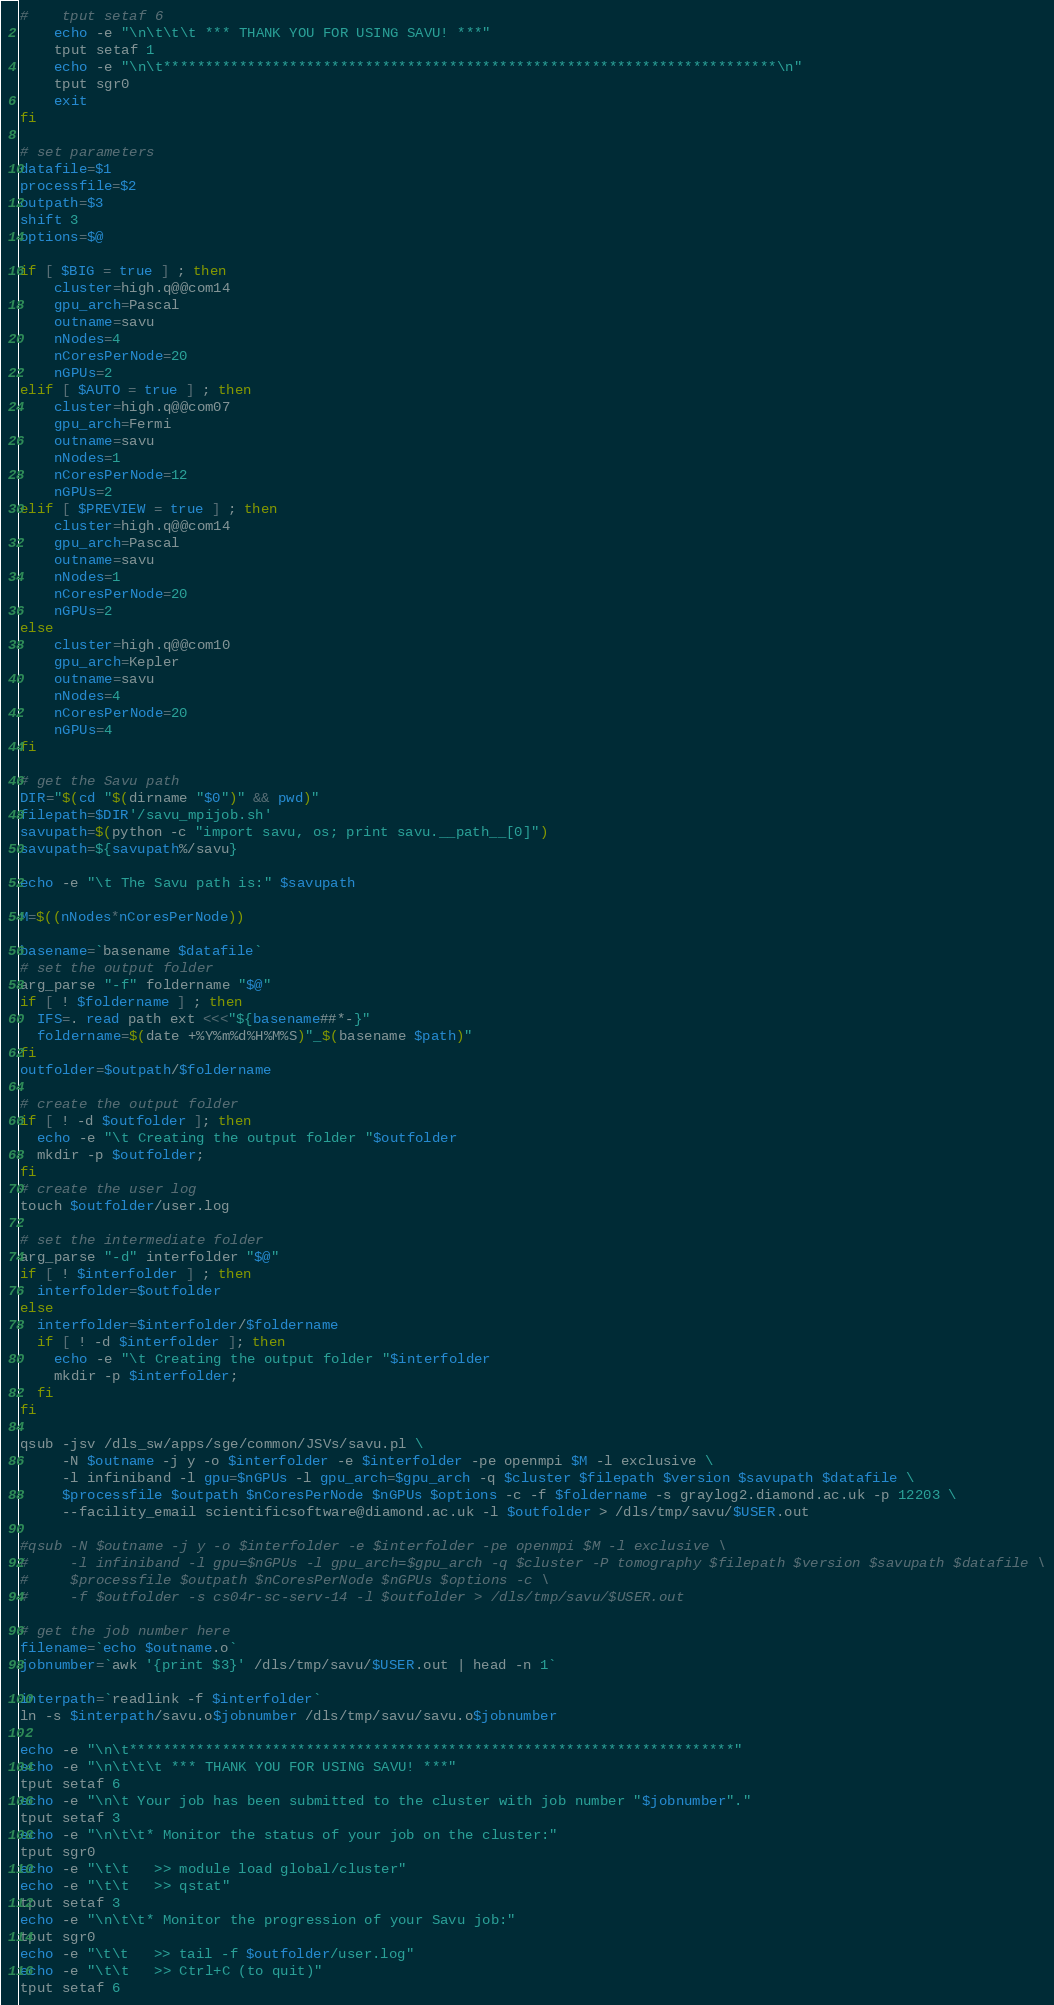<code> <loc_0><loc_0><loc_500><loc_500><_Bash_>#    tput setaf 6
    echo -e "\n\t\t\t *** THANK YOU FOR USING SAVU! ***"
    tput setaf 1
    echo -e "\n\t*************************************************************************\n"
    tput sgr0
    exit
fi

# set parameters
datafile=$1
processfile=$2
outpath=$3
shift 3
options=$@

if [ $BIG = true ] ; then
    cluster=high.q@@com14
    gpu_arch=Pascal
    outname=savu
    nNodes=4
    nCoresPerNode=20
    nGPUs=2
elif [ $AUTO = true ] ; then
    cluster=high.q@@com07
    gpu_arch=Fermi
    outname=savu
    nNodes=1
    nCoresPerNode=12
    nGPUs=2
elif [ $PREVIEW = true ] ; then
    cluster=high.q@@com14
    gpu_arch=Pascal
    outname=savu
    nNodes=1
    nCoresPerNode=20
    nGPUs=2
else
    cluster=high.q@@com10
    gpu_arch=Kepler
    outname=savu
    nNodes=4
    nCoresPerNode=20
    nGPUs=4
fi

# get the Savu path
DIR="$(cd "$(dirname "$0")" && pwd)"
filepath=$DIR'/savu_mpijob.sh'
savupath=$(python -c "import savu, os; print savu.__path__[0]")
savupath=${savupath%/savu}

echo -e "\t The Savu path is:" $savupath

M=$((nNodes*nCoresPerNode))

basename=`basename $datafile`
# set the output folder
arg_parse "-f" foldername "$@"
if [ ! $foldername ] ; then
  IFS=. read path ext <<<"${basename##*-}"
  foldername=$(date +%Y%m%d%H%M%S)"_$(basename $path)"
fi
outfolder=$outpath/$foldername

# create the output folder
if [ ! -d $outfolder ]; then
  echo -e "\t Creating the output folder "$outfolder
  mkdir -p $outfolder;
fi
# create the user log
touch $outfolder/user.log

# set the intermediate folder
arg_parse "-d" interfolder "$@"
if [ ! $interfolder ] ; then
  interfolder=$outfolder
else
  interfolder=$interfolder/$foldername
  if [ ! -d $interfolder ]; then
    echo -e "\t Creating the output folder "$interfolder
    mkdir -p $interfolder;
  fi
fi

qsub -jsv /dls_sw/apps/sge/common/JSVs/savu.pl \
     -N $outname -j y -o $interfolder -e $interfolder -pe openmpi $M -l exclusive \
     -l infiniband -l gpu=$nGPUs -l gpu_arch=$gpu_arch -q $cluster $filepath $version $savupath $datafile \
     $processfile $outpath $nCoresPerNode $nGPUs $options -c -f $foldername -s graylog2.diamond.ac.uk -p 12203 \
     --facility_email scientificsoftware@diamond.ac.uk -l $outfolder > /dls/tmp/savu/$USER.out

#qsub -N $outname -j y -o $interfolder -e $interfolder -pe openmpi $M -l exclusive \
#     -l infiniband -l gpu=$nGPUs -l gpu_arch=$gpu_arch -q $cluster -P tomography $filepath $version $savupath $datafile \
#     $processfile $outpath $nCoresPerNode $nGPUs $options -c \
#     -f $outfolder -s cs04r-sc-serv-14 -l $outfolder > /dls/tmp/savu/$USER.out

# get the job number here
filename=`echo $outname.o`
jobnumber=`awk '{print $3}' /dls/tmp/savu/$USER.out | head -n 1`

interpath=`readlink -f $interfolder`
ln -s $interpath/savu.o$jobnumber /dls/tmp/savu/savu.o$jobnumber

echo -e "\n\t************************************************************************"
echo -e "\n\t\t\t *** THANK YOU FOR USING SAVU! ***"
tput setaf 6
echo -e "\n\t Your job has been submitted to the cluster with job number "$jobnumber"."
tput setaf 3
echo -e "\n\t\t* Monitor the status of your job on the cluster:"
tput sgr0
echo -e "\t\t   >> module load global/cluster"
echo -e "\t\t   >> qstat"
tput setaf 3
echo -e "\n\t\t* Monitor the progression of your Savu job:"
tput sgr0
echo -e "\t\t   >> tail -f $outfolder/user.log"
echo -e "\t\t   >> Ctrl+C (to quit)"
tput setaf 6</code> 